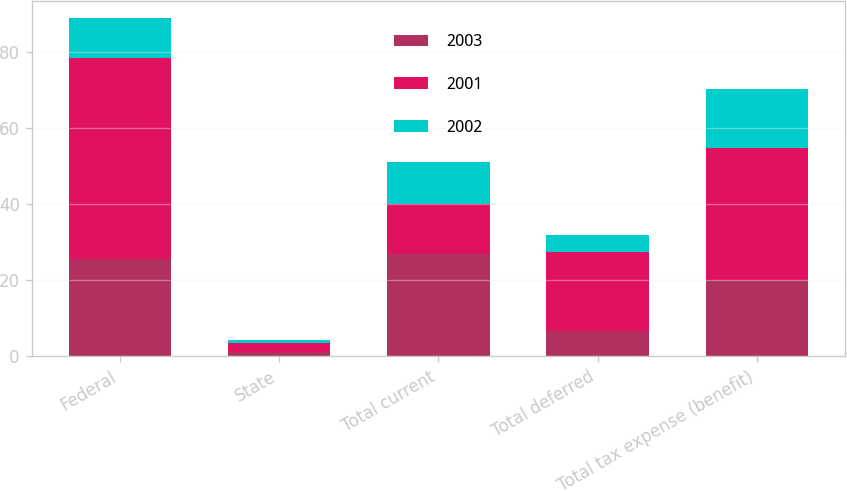Convert chart to OTSL. <chart><loc_0><loc_0><loc_500><loc_500><stacked_bar_chart><ecel><fcel>Federal<fcel>State<fcel>Total current<fcel>Total deferred<fcel>Total tax expense (benefit)<nl><fcel>2003<fcel>25.6<fcel>1.2<fcel>26.8<fcel>6.7<fcel>20.1<nl><fcel>2001<fcel>53<fcel>2.3<fcel>13.3<fcel>20.7<fcel>34.6<nl><fcel>2002<fcel>10.4<fcel>0.7<fcel>11.1<fcel>4.4<fcel>15.5<nl></chart> 